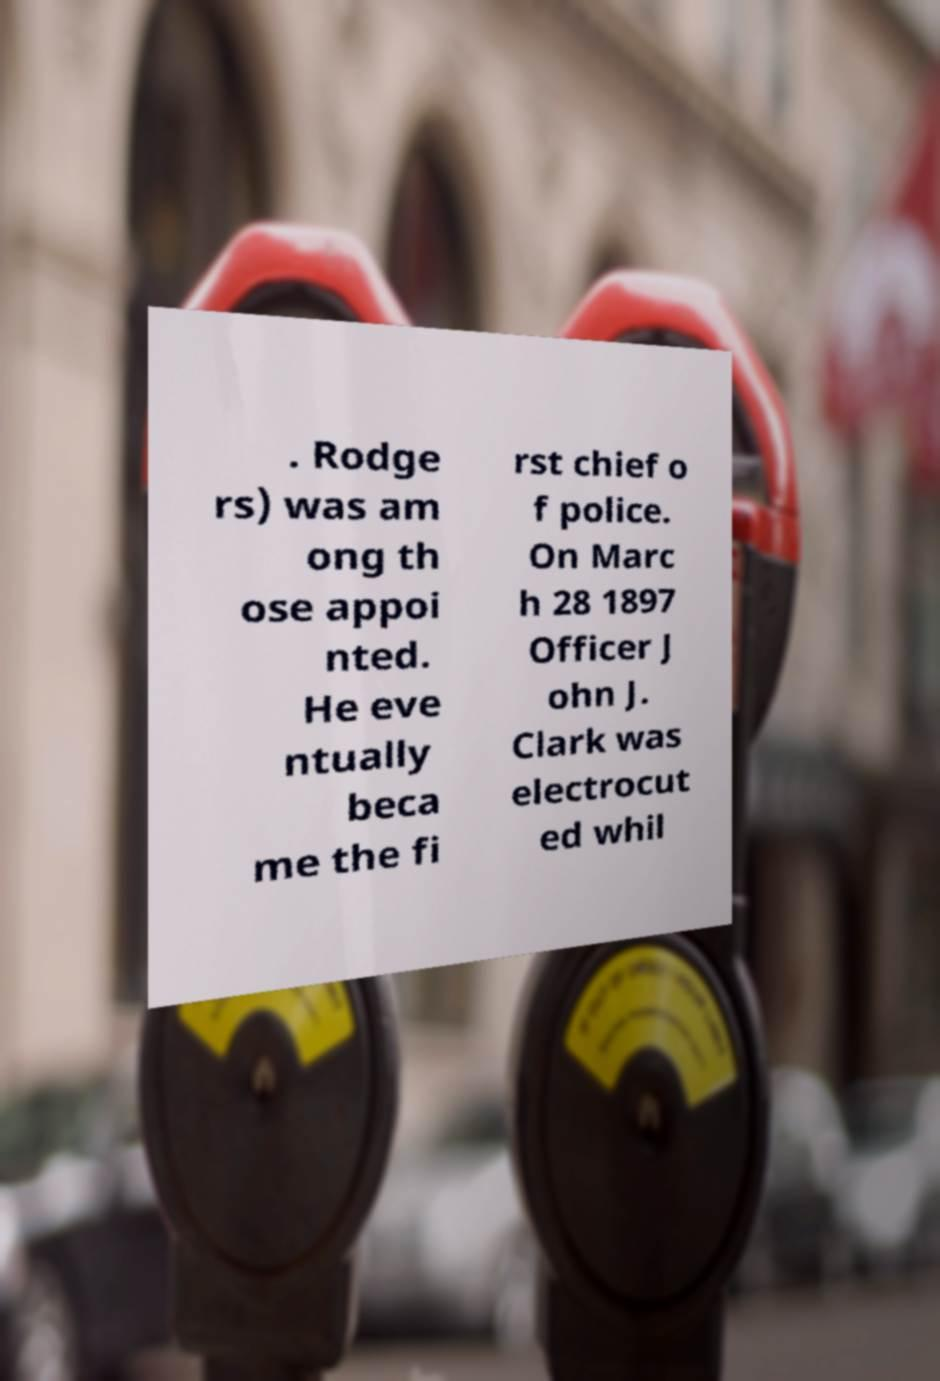Could you extract and type out the text from this image? . Rodge rs) was am ong th ose appoi nted. He eve ntually beca me the fi rst chief o f police. On Marc h 28 1897 Officer J ohn J. Clark was electrocut ed whil 